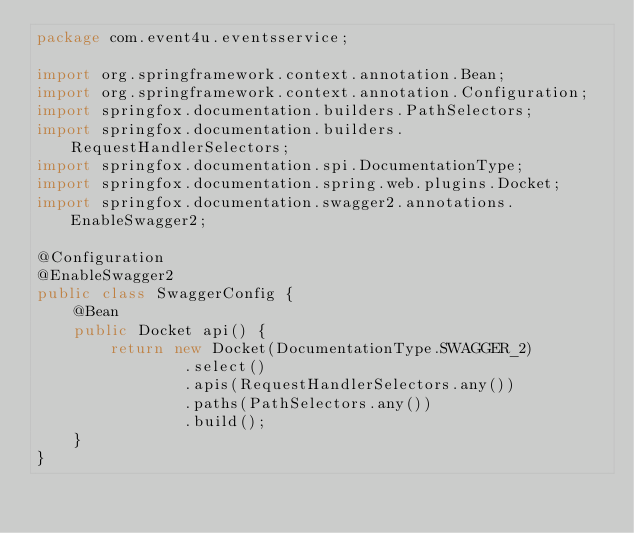Convert code to text. <code><loc_0><loc_0><loc_500><loc_500><_Java_>package com.event4u.eventsservice;

import org.springframework.context.annotation.Bean;
import org.springframework.context.annotation.Configuration;
import springfox.documentation.builders.PathSelectors;
import springfox.documentation.builders.RequestHandlerSelectors;
import springfox.documentation.spi.DocumentationType;
import springfox.documentation.spring.web.plugins.Docket;
import springfox.documentation.swagger2.annotations.EnableSwagger2;

@Configuration
@EnableSwagger2
public class SwaggerConfig {
    @Bean
    public Docket api() {
        return new Docket(DocumentationType.SWAGGER_2)
                .select()
                .apis(RequestHandlerSelectors.any())
                .paths(PathSelectors.any())
                .build();
    }
}
</code> 